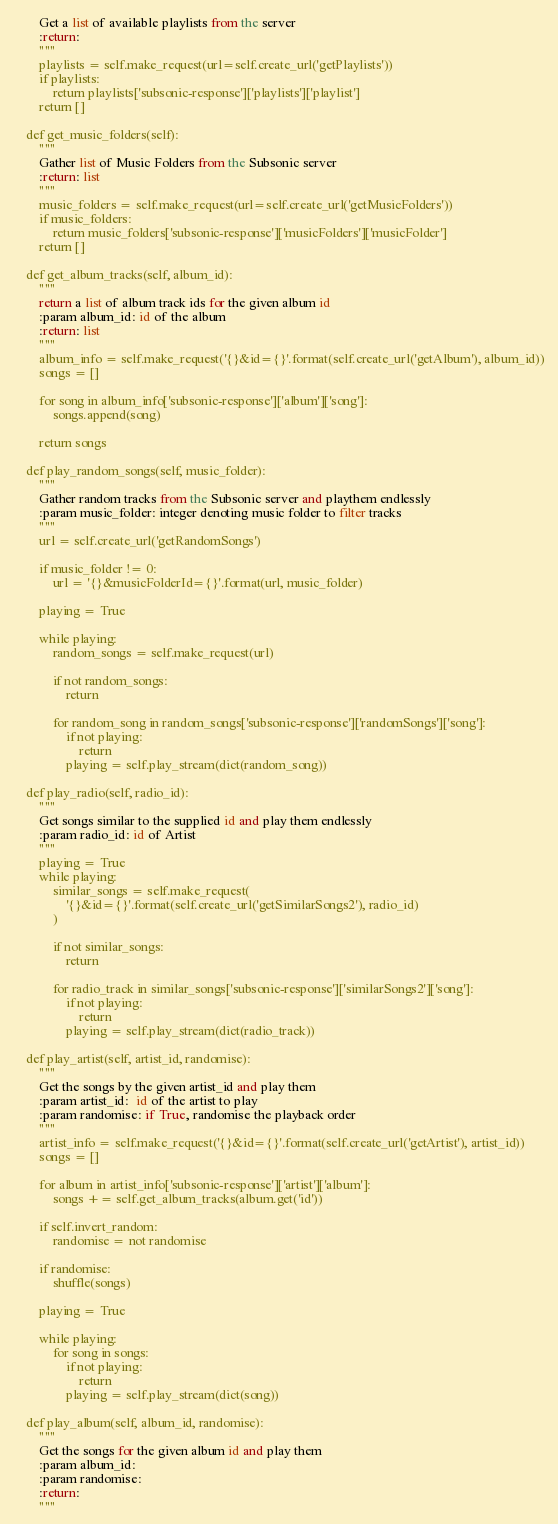Convert code to text. <code><loc_0><loc_0><loc_500><loc_500><_Python_>        Get a list of available playlists from the server
        :return:
        """
        playlists = self.make_request(url=self.create_url('getPlaylists'))
        if playlists:
            return playlists['subsonic-response']['playlists']['playlist']
        return []

    def get_music_folders(self):
        """
        Gather list of Music Folders from the Subsonic server
        :return: list
        """
        music_folders = self.make_request(url=self.create_url('getMusicFolders'))
        if music_folders:
            return music_folders['subsonic-response']['musicFolders']['musicFolder']
        return []

    def get_album_tracks(self, album_id):
        """
        return a list of album track ids for the given album id
        :param album_id: id of the album
        :return: list
        """
        album_info = self.make_request('{}&id={}'.format(self.create_url('getAlbum'), album_id))
        songs = []

        for song in album_info['subsonic-response']['album']['song']:
            songs.append(song)

        return songs

    def play_random_songs(self, music_folder):
        """
        Gather random tracks from the Subsonic server and playthem endlessly
        :param music_folder: integer denoting music folder to filter tracks
        """
        url = self.create_url('getRandomSongs')

        if music_folder != 0:
            url = '{}&musicFolderId={}'.format(url, music_folder)

        playing = True

        while playing:
            random_songs = self.make_request(url)

            if not random_songs:
                return

            for random_song in random_songs['subsonic-response']['randomSongs']['song']:
                if not playing:
                    return
                playing = self.play_stream(dict(random_song))

    def play_radio(self, radio_id):
        """
        Get songs similar to the supplied id and play them endlessly
        :param radio_id: id of Artist
        """
        playing = True
        while playing:
            similar_songs = self.make_request(
                '{}&id={}'.format(self.create_url('getSimilarSongs2'), radio_id)
            )

            if not similar_songs:
                return

            for radio_track in similar_songs['subsonic-response']['similarSongs2']['song']:
                if not playing:
                    return
                playing = self.play_stream(dict(radio_track))

    def play_artist(self, artist_id, randomise):
        """
        Get the songs by the given artist_id and play them
        :param artist_id:  id of the artist to play
        :param randomise: if True, randomise the playback order
        """
        artist_info = self.make_request('{}&id={}'.format(self.create_url('getArtist'), artist_id))
        songs = []

        for album in artist_info['subsonic-response']['artist']['album']:
            songs += self.get_album_tracks(album.get('id'))

        if self.invert_random:
            randomise = not randomise

        if randomise:
            shuffle(songs)

        playing = True

        while playing:
            for song in songs:
                if not playing:
                    return
                playing = self.play_stream(dict(song))

    def play_album(self, album_id, randomise):
        """
        Get the songs for the given album id and play them
        :param album_id:
        :param randomise:
        :return:
        """</code> 